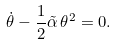Convert formula to latex. <formula><loc_0><loc_0><loc_500><loc_500>\dot { \theta } - \frac { 1 } { 2 } \tilde { \alpha } \, \theta ^ { 2 } = 0 .</formula> 